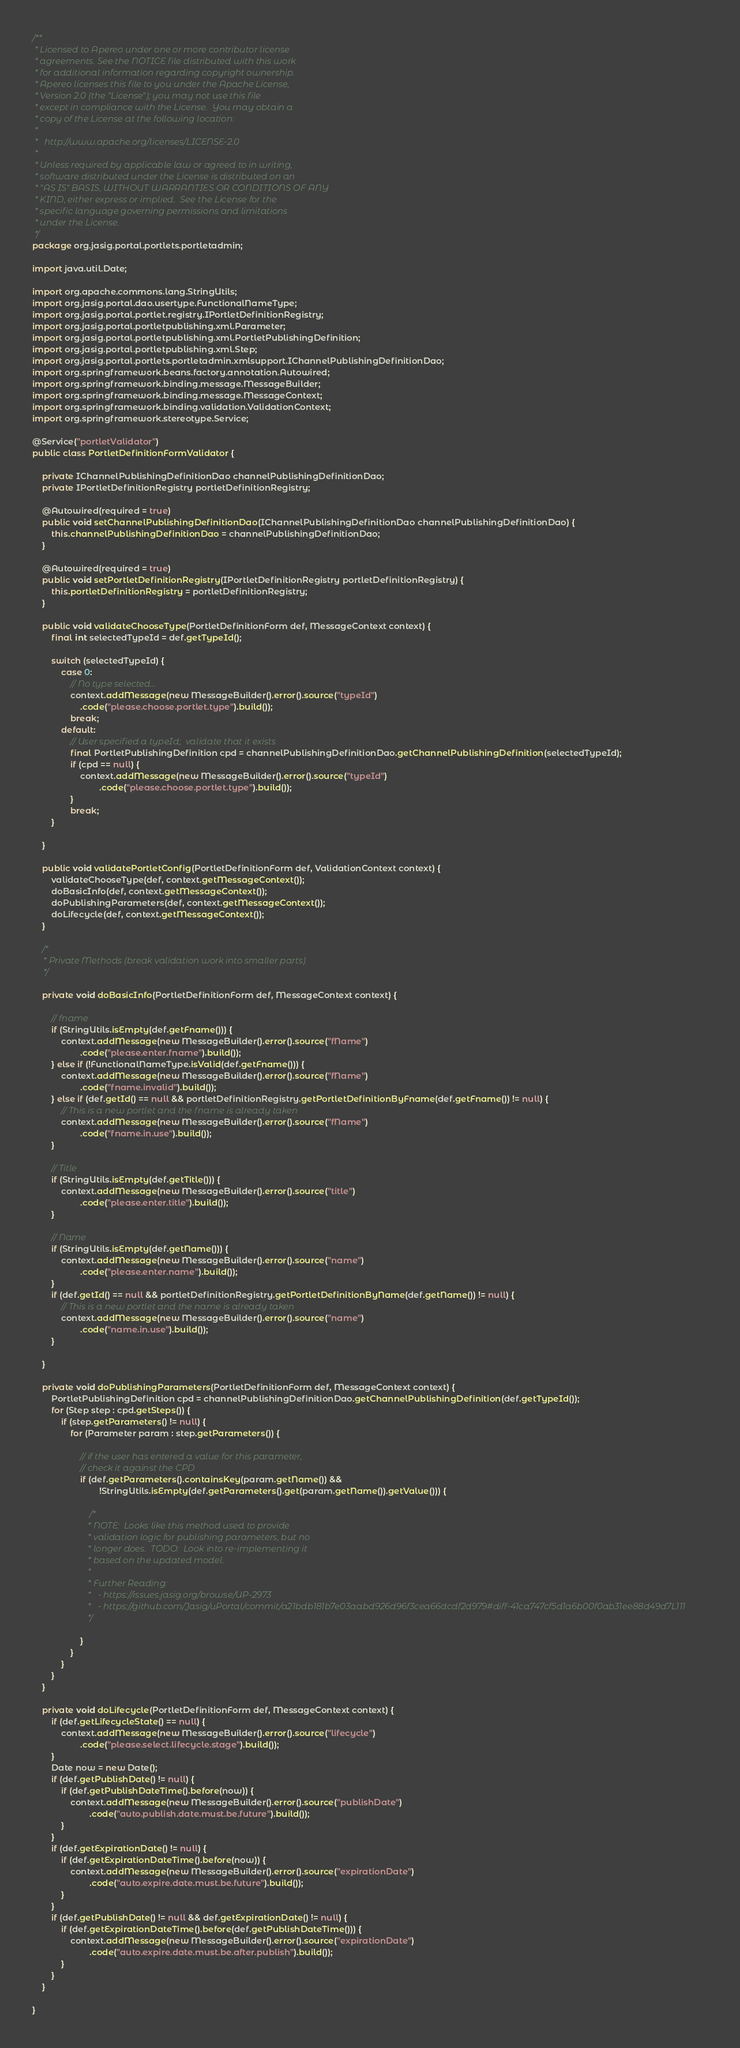<code> <loc_0><loc_0><loc_500><loc_500><_Java_>/**
 * Licensed to Apereo under one or more contributor license
 * agreements. See the NOTICE file distributed with this work
 * for additional information regarding copyright ownership.
 * Apereo licenses this file to you under the Apache License,
 * Version 2.0 (the "License"); you may not use this file
 * except in compliance with the License.  You may obtain a
 * copy of the License at the following location:
 *
 *   http://www.apache.org/licenses/LICENSE-2.0
 *
 * Unless required by applicable law or agreed to in writing,
 * software distributed under the License is distributed on an
 * "AS IS" BASIS, WITHOUT WARRANTIES OR CONDITIONS OF ANY
 * KIND, either express or implied.  See the License for the
 * specific language governing permissions and limitations
 * under the License.
 */
package org.jasig.portal.portlets.portletadmin;

import java.util.Date;

import org.apache.commons.lang.StringUtils;
import org.jasig.portal.dao.usertype.FunctionalNameType;
import org.jasig.portal.portlet.registry.IPortletDefinitionRegistry;
import org.jasig.portal.portletpublishing.xml.Parameter;
import org.jasig.portal.portletpublishing.xml.PortletPublishingDefinition;
import org.jasig.portal.portletpublishing.xml.Step;
import org.jasig.portal.portlets.portletadmin.xmlsupport.IChannelPublishingDefinitionDao;
import org.springframework.beans.factory.annotation.Autowired;
import org.springframework.binding.message.MessageBuilder;
import org.springframework.binding.message.MessageContext;
import org.springframework.binding.validation.ValidationContext;
import org.springframework.stereotype.Service;

@Service("portletValidator")
public class PortletDefinitionFormValidator {

    private IChannelPublishingDefinitionDao channelPublishingDefinitionDao;
    private IPortletDefinitionRegistry portletDefinitionRegistry;

    @Autowired(required = true)
    public void setChannelPublishingDefinitionDao(IChannelPublishingDefinitionDao channelPublishingDefinitionDao) {
        this.channelPublishingDefinitionDao = channelPublishingDefinitionDao;
    }

    @Autowired(required = true)
    public void setPortletDefinitionRegistry(IPortletDefinitionRegistry portletDefinitionRegistry) {
        this.portletDefinitionRegistry = portletDefinitionRegistry;
    }

    public void validateChooseType(PortletDefinitionForm def, MessageContext context) {
        final int selectedTypeId = def.getTypeId();

        switch (selectedTypeId) {
            case 0:
                // No type selected...
                context.addMessage(new MessageBuilder().error().source("typeId")
                    .code("please.choose.portlet.type").build());
                break;
            default:
                // User specified a typeId;  validate that it exists
                final PortletPublishingDefinition cpd = channelPublishingDefinitionDao.getChannelPublishingDefinition(selectedTypeId);
                if (cpd == null) {
                    context.addMessage(new MessageBuilder().error().source("typeId")
                            .code("please.choose.portlet.type").build());
                }
                break;
        }

    }

    public void validatePortletConfig(PortletDefinitionForm def, ValidationContext context) {
        validateChooseType(def, context.getMessageContext());
        doBasicInfo(def, context.getMessageContext());
        doPublishingParameters(def, context.getMessageContext());
        doLifecycle(def, context.getMessageContext());
    }

    /*
     * Private Methods (break validation work into smaller parts)
     */

    private void doBasicInfo(PortletDefinitionForm def, MessageContext context) {

        // fname
        if (StringUtils.isEmpty(def.getFname())) {
            context.addMessage(new MessageBuilder().error().source("fName")
                    .code("please.enter.fname").build());
        } else if (!FunctionalNameType.isValid(def.getFname())) {
            context.addMessage(new MessageBuilder().error().source("fName")
                    .code("fname.invalid").build());
        } else if (def.getId() == null && portletDefinitionRegistry.getPortletDefinitionByFname(def.getFname()) != null) {
            // This is a new portlet and the fname is already taken
            context.addMessage(new MessageBuilder().error().source("fName")
                    .code("fname.in.use").build());
        }

        // Title
        if (StringUtils.isEmpty(def.getTitle())) {
            context.addMessage(new MessageBuilder().error().source("title")
                    .code("please.enter.title").build());
        }

        // Name
        if (StringUtils.isEmpty(def.getName())) {
            context.addMessage(new MessageBuilder().error().source("name")
                    .code("please.enter.name").build());
        }
        if (def.getId() == null && portletDefinitionRegistry.getPortletDefinitionByName(def.getName()) != null) {
            // This is a new portlet and the name is already taken
            context.addMessage(new MessageBuilder().error().source("name")
                    .code("name.in.use").build());
        }

    }

    private void doPublishingParameters(PortletDefinitionForm def, MessageContext context) {
        PortletPublishingDefinition cpd = channelPublishingDefinitionDao.getChannelPublishingDefinition(def.getTypeId());
        for (Step step : cpd.getSteps()) {
            if (step.getParameters() != null) {
                for (Parameter param : step.getParameters()) {

                    // if the user has entered a value for this parameter, 
                    // check it against the CPD
                    if (def.getParameters().containsKey(param.getName()) && 
                            !StringUtils.isEmpty(def.getParameters().get(param.getName()).getValue())) {

                        /*
                         * NOTE:  Looks like this method used to provide
                         * validation logic for publishing parameters, but no
                         * longer does.  TODO:  Look into re-implementing it
                         * based on the updated model.
                         * 
                         * Further Reading:
                         *   - https://issues.jasig.org/browse/UP-2973
                         *   - https://github.com/Jasig/uPortal/commit/a21bdb181b7e03aabd926d96f3cea66dcdf2d979#diff-41ca747cf5d1a6b00f0ab31ee88d49d7L111
                         */

                    }
                }
            }
        }
    }

    private void doLifecycle(PortletDefinitionForm def, MessageContext context) {
        if (def.getLifecycleState() == null) {
            context.addMessage(new MessageBuilder().error().source("lifecycle")
                    .code("please.select.lifecycle.stage").build());
        }
        Date now = new Date();
        if (def.getPublishDate() != null) {
            if (def.getPublishDateTime().before(now)) {
                context.addMessage(new MessageBuilder().error().source("publishDate")
                        .code("auto.publish.date.must.be.future").build());
            }
        }
        if (def.getExpirationDate() != null) {
            if (def.getExpirationDateTime().before(now)) {
                context.addMessage(new MessageBuilder().error().source("expirationDate")
                        .code("auto.expire.date.must.be.future").build());
            }
        }
        if (def.getPublishDate() != null && def.getExpirationDate() != null) {
            if (def.getExpirationDateTime().before(def.getPublishDateTime())) {
                context.addMessage(new MessageBuilder().error().source("expirationDate")
                        .code("auto.expire.date.must.be.after.publish").build());
            }
        }
    }

}
</code> 